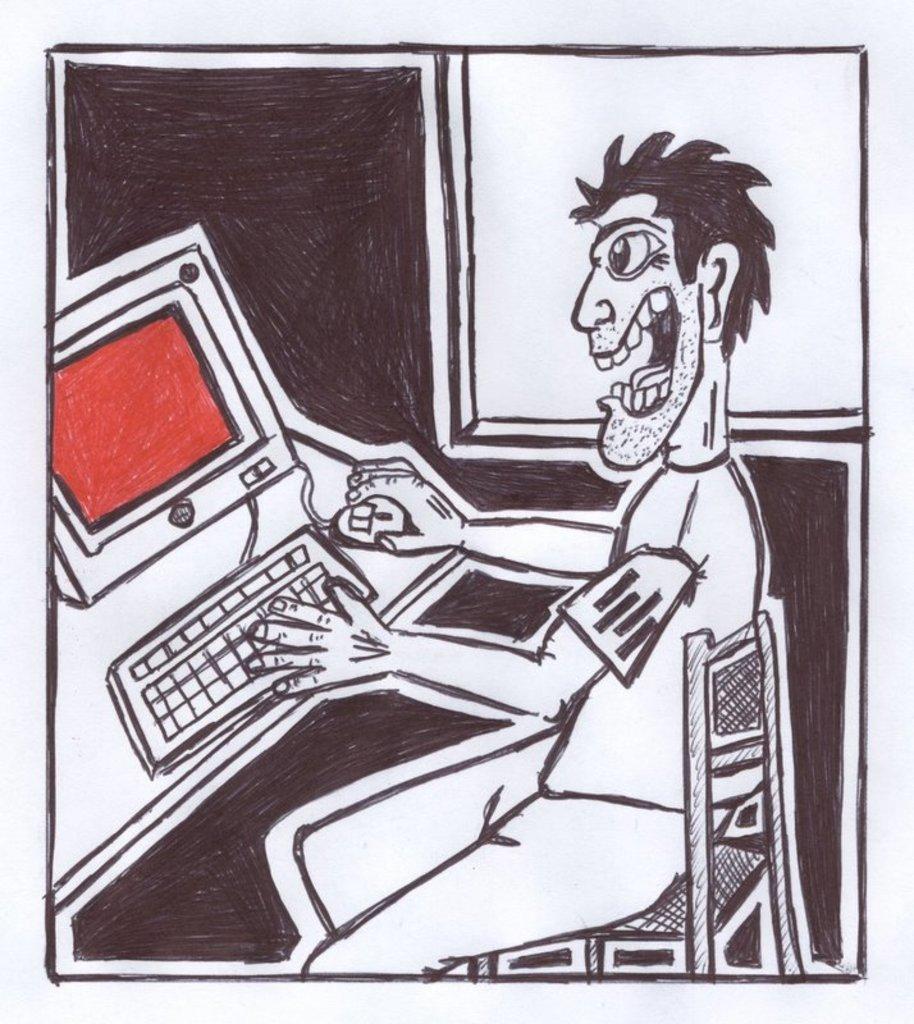Can you describe this image briefly? In the image we can see a drawing on the paper. There is a drawing of a person sitting on the chair and a system. 